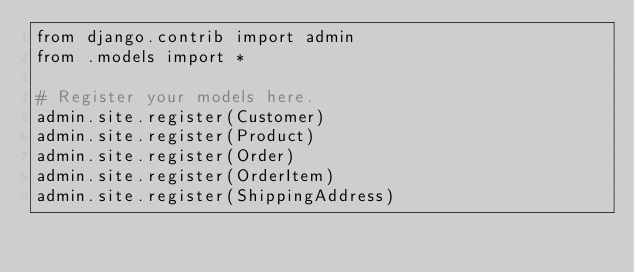Convert code to text. <code><loc_0><loc_0><loc_500><loc_500><_Python_>from django.contrib import admin
from .models import *

# Register your models here.
admin.site.register(Customer)
admin.site.register(Product)
admin.site.register(Order)
admin.site.register(OrderItem)
admin.site.register(ShippingAddress)
</code> 